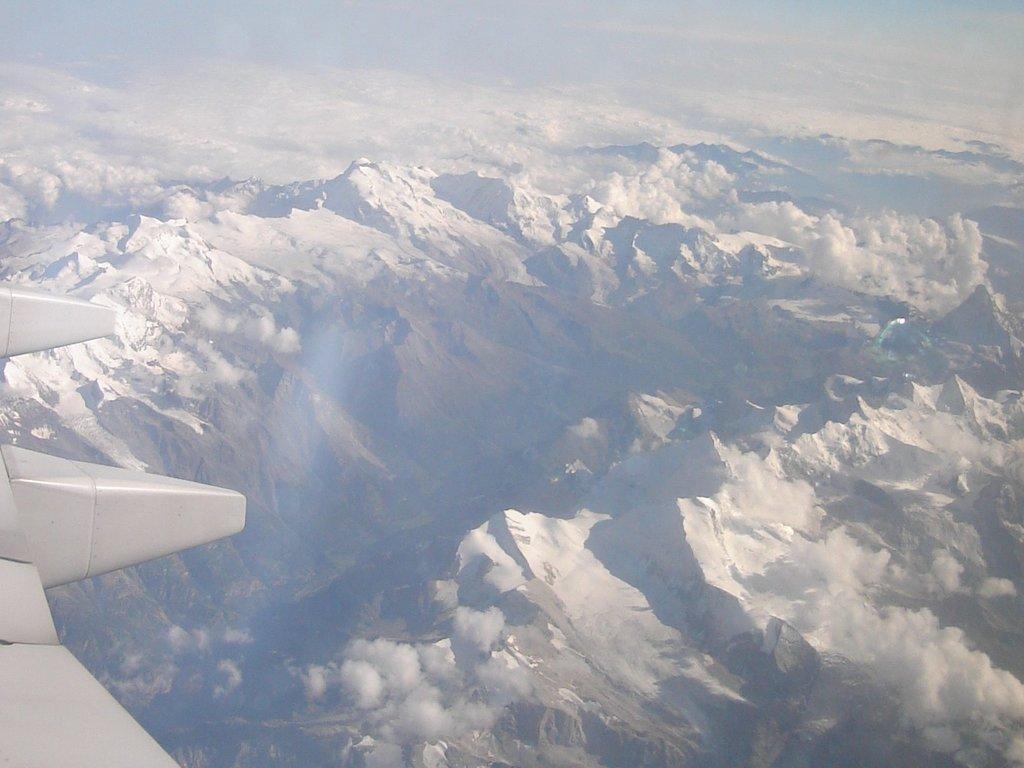Describe this image in one or two sentences. In this image we can see the aerial view of the mountains. 